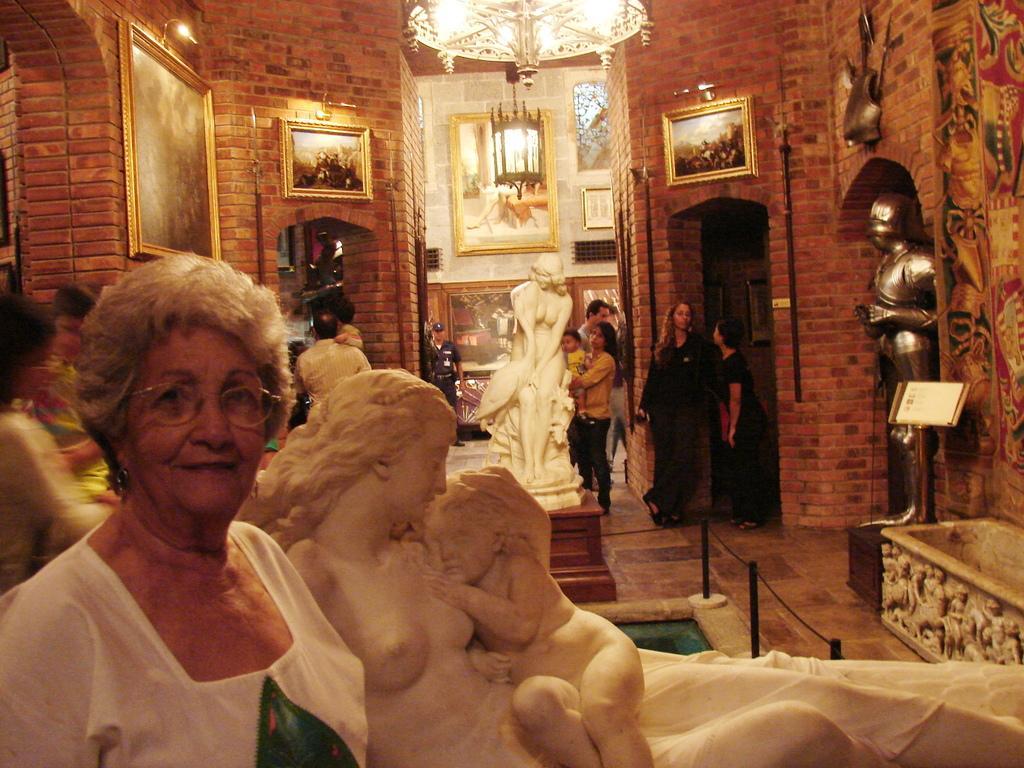In one or two sentences, can you explain what this image depicts? In this picture I can see there is a woman standing, she is wearing a white dress and she has spectacles, there is a statue of a woman and she is holding a child behind her. There is another statue of a woman in the backdrop and there are a few people standing and there are few photo frames placed on the wall, there are few lights attached to the ceiling and there is an Armour at right side and in the backdrop there are few more photo frames and there is a security guard standing. 